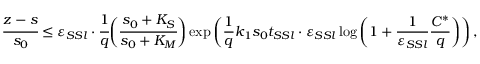<formula> <loc_0><loc_0><loc_500><loc_500>\cfrac { z - s } { s _ { 0 } } \leq \varepsilon _ { S S l } \cdot \cfrac { 1 } { q } \left ( \cfrac { s _ { 0 } + K _ { S } } { s _ { 0 } + K _ { M } } \right ) \exp \left ( \frac { 1 } { q } k _ { 1 } s _ { 0 } t _ { S S l } \cdot \varepsilon _ { S S l } \log \left ( 1 + \frac { 1 } { \varepsilon _ { S S l } } \frac { C ^ { * } } { q } \right ) \right ) ,</formula> 